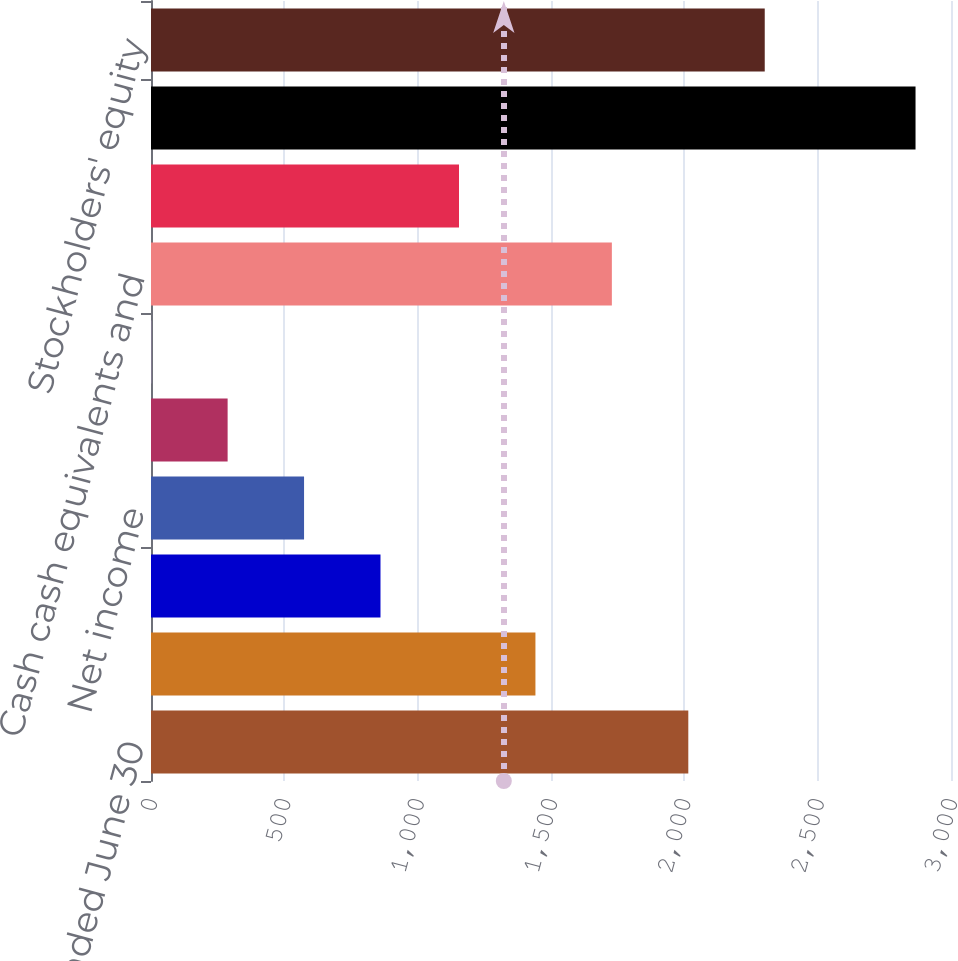Convert chart. <chart><loc_0><loc_0><loc_500><loc_500><bar_chart><fcel>Years ended June 30<fcel>Revenues<fcel>Income from operations<fcel>Net income<fcel>Basic<fcel>Diluted<fcel>Cash cash equivalents and<fcel>Working capital<fcel>Total assets<fcel>Stockholders' equity<nl><fcel>2014.89<fcel>1441.63<fcel>860.59<fcel>573.96<fcel>287.33<fcel>0.7<fcel>1728.26<fcel>1155<fcel>2867<fcel>2301.52<nl></chart> 